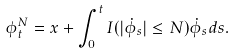<formula> <loc_0><loc_0><loc_500><loc_500>\phi ^ { N } _ { t } = x + \int _ { 0 } ^ { t } I ( | \dot { \phi } _ { s } | \leq N ) \dot { \phi } _ { s } d s .</formula> 